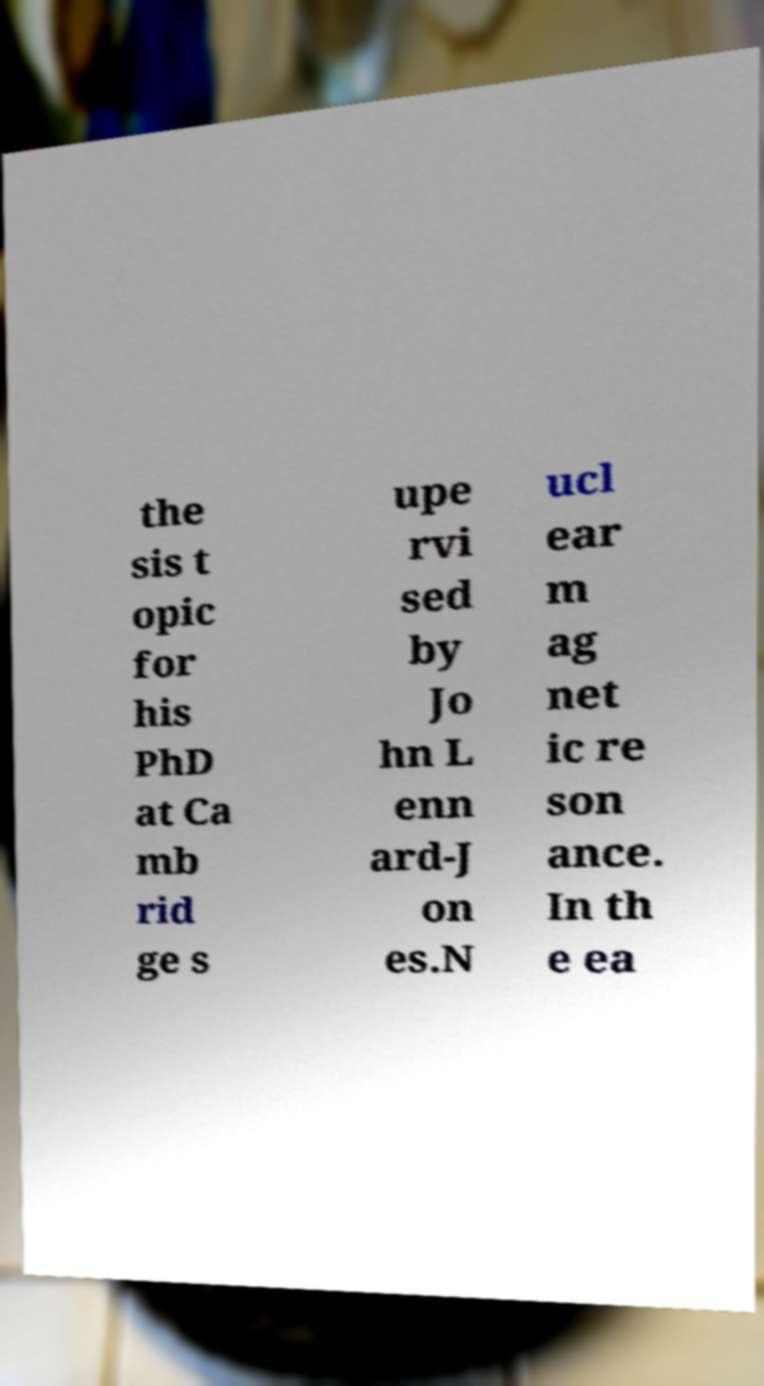Can you accurately transcribe the text from the provided image for me? the sis t opic for his PhD at Ca mb rid ge s upe rvi sed by Jo hn L enn ard-J on es.N ucl ear m ag net ic re son ance. In th e ea 